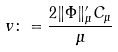<formula> <loc_0><loc_0><loc_500><loc_500>v \colon = \frac { 2 \| \Phi \| _ { \mu } ^ { \prime } C _ { \mu } } { \mu }</formula> 